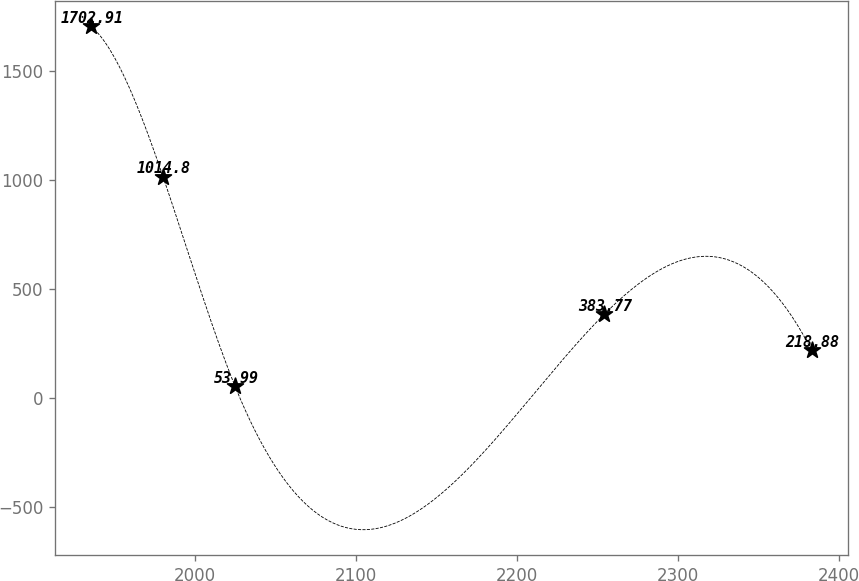<chart> <loc_0><loc_0><loc_500><loc_500><line_chart><ecel><fcel>Unnamed: 1<nl><fcel>1935.63<fcel>1702.91<nl><fcel>1980.38<fcel>1014.8<nl><fcel>2025.13<fcel>53.99<nl><fcel>2254.28<fcel>383.77<nl><fcel>2383.09<fcel>218.88<nl></chart> 